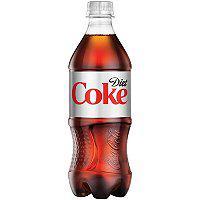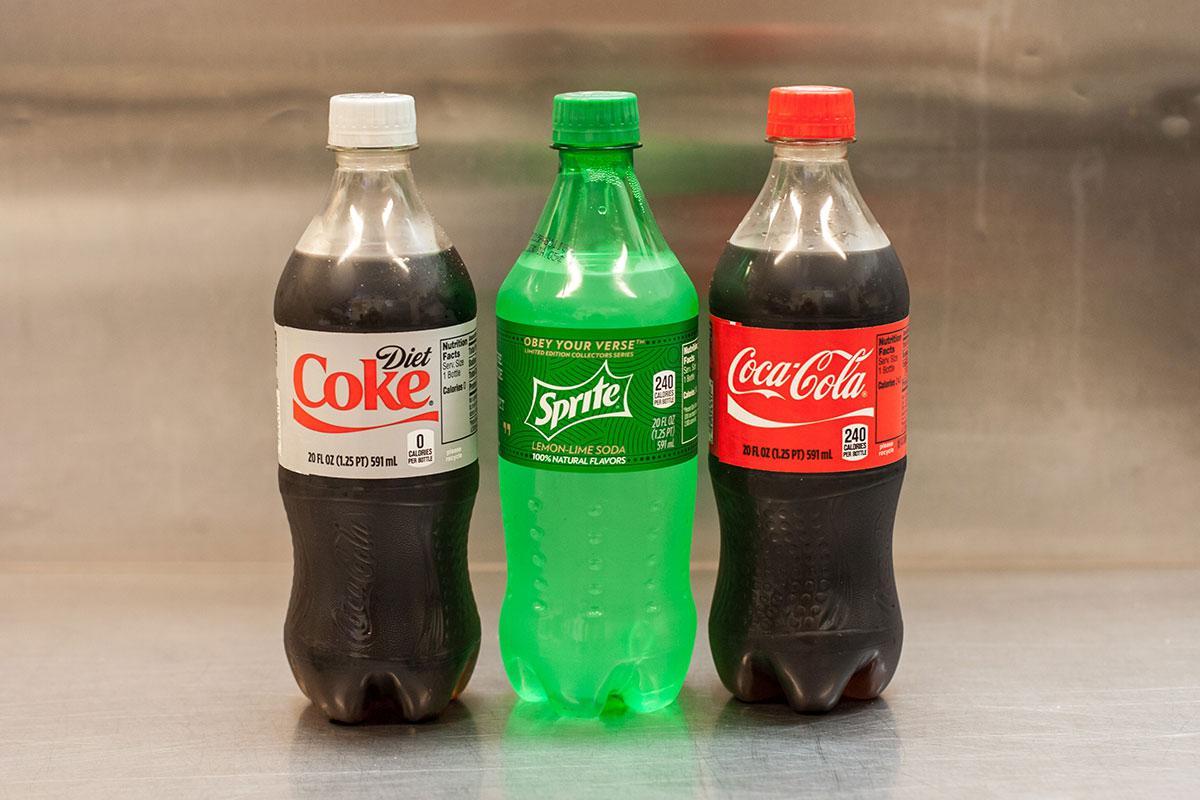The first image is the image on the left, the second image is the image on the right. Examine the images to the left and right. Is the description "Only plastic, filled soda bottles with lids and labels are shown, and the left image features at least one bottle with a semi-hourglass shape, while the right image shows three bottles with different labels." accurate? Answer yes or no. Yes. The first image is the image on the left, the second image is the image on the right. Examine the images to the left and right. Is the description "In the right image, there is a green colored plastic soda bottle" accurate? Answer yes or no. Yes. 